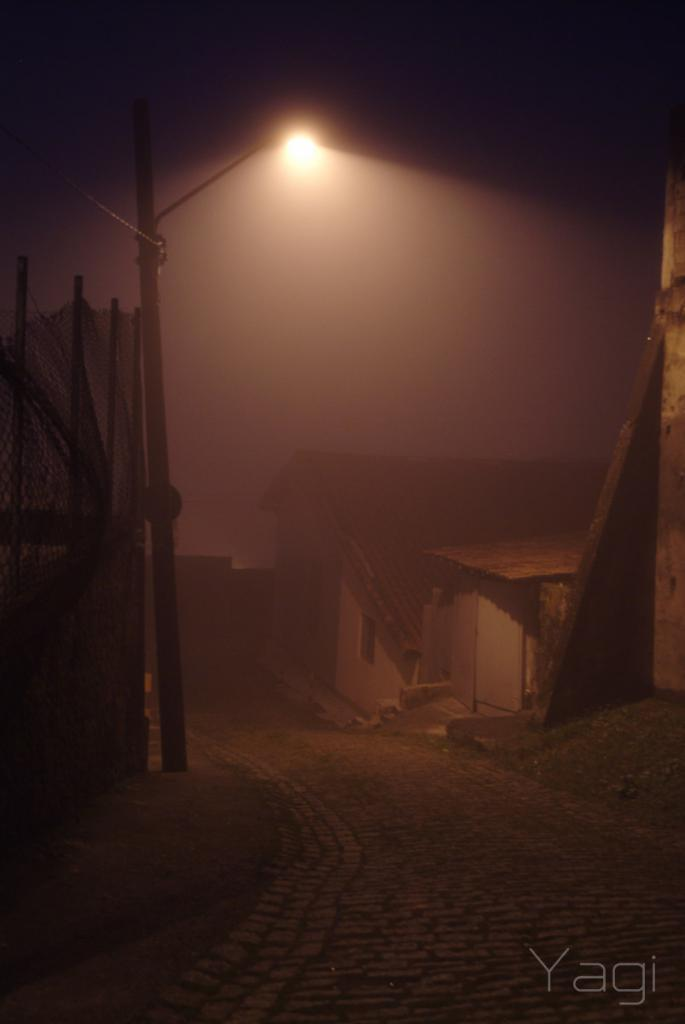What is the main structure in the image? There is a pole in the image. What is attached to the pole? A street light is attached to the pole. What type of barrier is present in the image? There is fencing in the image. What type of dwelling can be seen in the image? There are huts in the image. How many cats are sitting on the huts in the image? There are no cats present in the image; it only features huts, a pole, a street light, and fencing. 